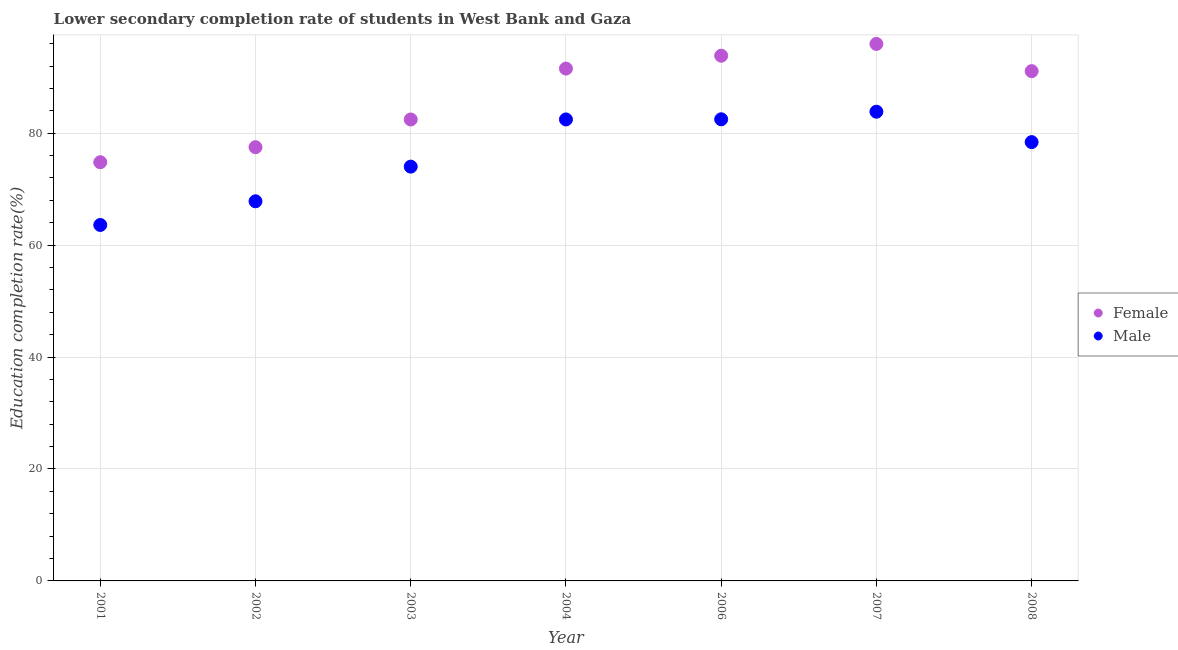How many different coloured dotlines are there?
Provide a succinct answer. 2. Is the number of dotlines equal to the number of legend labels?
Provide a succinct answer. Yes. What is the education completion rate of male students in 2002?
Offer a terse response. 67.83. Across all years, what is the maximum education completion rate of male students?
Make the answer very short. 83.84. Across all years, what is the minimum education completion rate of female students?
Your answer should be very brief. 74.81. What is the total education completion rate of female students in the graph?
Your answer should be compact. 607.18. What is the difference between the education completion rate of female students in 2001 and that in 2007?
Keep it short and to the point. -21.14. What is the difference between the education completion rate of male students in 2003 and the education completion rate of female students in 2007?
Provide a succinct answer. -21.92. What is the average education completion rate of male students per year?
Ensure brevity in your answer.  76.09. In the year 2008, what is the difference between the education completion rate of male students and education completion rate of female students?
Offer a very short reply. -12.68. What is the ratio of the education completion rate of female students in 2004 to that in 2006?
Provide a short and direct response. 0.98. Is the difference between the education completion rate of male students in 2002 and 2003 greater than the difference between the education completion rate of female students in 2002 and 2003?
Your response must be concise. No. What is the difference between the highest and the second highest education completion rate of female students?
Provide a succinct answer. 2.11. What is the difference between the highest and the lowest education completion rate of female students?
Offer a very short reply. 21.14. In how many years, is the education completion rate of male students greater than the average education completion rate of male students taken over all years?
Make the answer very short. 4. Does the education completion rate of male students monotonically increase over the years?
Provide a short and direct response. No. Is the education completion rate of male students strictly greater than the education completion rate of female students over the years?
Your answer should be compact. No. Is the education completion rate of male students strictly less than the education completion rate of female students over the years?
Offer a very short reply. Yes. How many years are there in the graph?
Give a very brief answer. 7. What is the difference between two consecutive major ticks on the Y-axis?
Your answer should be very brief. 20. Does the graph contain grids?
Your answer should be compact. Yes. Where does the legend appear in the graph?
Give a very brief answer. Center right. How are the legend labels stacked?
Give a very brief answer. Vertical. What is the title of the graph?
Provide a short and direct response. Lower secondary completion rate of students in West Bank and Gaza. Does "Excluding technical cooperation" appear as one of the legend labels in the graph?
Ensure brevity in your answer.  No. What is the label or title of the Y-axis?
Ensure brevity in your answer.  Education completion rate(%). What is the Education completion rate(%) in Female in 2001?
Provide a succinct answer. 74.81. What is the Education completion rate(%) of Male in 2001?
Provide a short and direct response. 63.6. What is the Education completion rate(%) of Female in 2002?
Your answer should be very brief. 77.5. What is the Education completion rate(%) in Male in 2002?
Make the answer very short. 67.83. What is the Education completion rate(%) of Female in 2003?
Keep it short and to the point. 82.45. What is the Education completion rate(%) in Male in 2003?
Ensure brevity in your answer.  74.02. What is the Education completion rate(%) in Female in 2004?
Offer a very short reply. 91.54. What is the Education completion rate(%) of Male in 2004?
Give a very brief answer. 82.46. What is the Education completion rate(%) of Female in 2006?
Offer a terse response. 93.84. What is the Education completion rate(%) of Male in 2006?
Make the answer very short. 82.48. What is the Education completion rate(%) of Female in 2007?
Provide a succinct answer. 95.95. What is the Education completion rate(%) of Male in 2007?
Give a very brief answer. 83.84. What is the Education completion rate(%) in Female in 2008?
Ensure brevity in your answer.  91.09. What is the Education completion rate(%) in Male in 2008?
Provide a short and direct response. 78.41. Across all years, what is the maximum Education completion rate(%) in Female?
Offer a terse response. 95.95. Across all years, what is the maximum Education completion rate(%) in Male?
Keep it short and to the point. 83.84. Across all years, what is the minimum Education completion rate(%) of Female?
Offer a very short reply. 74.81. Across all years, what is the minimum Education completion rate(%) of Male?
Offer a very short reply. 63.6. What is the total Education completion rate(%) in Female in the graph?
Keep it short and to the point. 607.18. What is the total Education completion rate(%) in Male in the graph?
Provide a short and direct response. 532.65. What is the difference between the Education completion rate(%) of Female in 2001 and that in 2002?
Give a very brief answer. -2.69. What is the difference between the Education completion rate(%) in Male in 2001 and that in 2002?
Provide a short and direct response. -4.23. What is the difference between the Education completion rate(%) of Female in 2001 and that in 2003?
Your response must be concise. -7.64. What is the difference between the Education completion rate(%) in Male in 2001 and that in 2003?
Offer a very short reply. -10.42. What is the difference between the Education completion rate(%) in Female in 2001 and that in 2004?
Offer a terse response. -16.73. What is the difference between the Education completion rate(%) in Male in 2001 and that in 2004?
Give a very brief answer. -18.86. What is the difference between the Education completion rate(%) in Female in 2001 and that in 2006?
Your response must be concise. -19.03. What is the difference between the Education completion rate(%) in Male in 2001 and that in 2006?
Ensure brevity in your answer.  -18.88. What is the difference between the Education completion rate(%) in Female in 2001 and that in 2007?
Your answer should be compact. -21.14. What is the difference between the Education completion rate(%) in Male in 2001 and that in 2007?
Offer a terse response. -20.24. What is the difference between the Education completion rate(%) in Female in 2001 and that in 2008?
Provide a short and direct response. -16.27. What is the difference between the Education completion rate(%) in Male in 2001 and that in 2008?
Ensure brevity in your answer.  -14.81. What is the difference between the Education completion rate(%) in Female in 2002 and that in 2003?
Your response must be concise. -4.95. What is the difference between the Education completion rate(%) of Male in 2002 and that in 2003?
Offer a terse response. -6.19. What is the difference between the Education completion rate(%) of Female in 2002 and that in 2004?
Offer a terse response. -14.05. What is the difference between the Education completion rate(%) in Male in 2002 and that in 2004?
Keep it short and to the point. -14.62. What is the difference between the Education completion rate(%) in Female in 2002 and that in 2006?
Make the answer very short. -16.34. What is the difference between the Education completion rate(%) of Male in 2002 and that in 2006?
Provide a short and direct response. -14.65. What is the difference between the Education completion rate(%) in Female in 2002 and that in 2007?
Offer a terse response. -18.45. What is the difference between the Education completion rate(%) in Male in 2002 and that in 2007?
Your response must be concise. -16. What is the difference between the Education completion rate(%) in Female in 2002 and that in 2008?
Your answer should be very brief. -13.59. What is the difference between the Education completion rate(%) in Male in 2002 and that in 2008?
Keep it short and to the point. -10.57. What is the difference between the Education completion rate(%) of Female in 2003 and that in 2004?
Your answer should be compact. -9.09. What is the difference between the Education completion rate(%) in Male in 2003 and that in 2004?
Make the answer very short. -8.43. What is the difference between the Education completion rate(%) in Female in 2003 and that in 2006?
Offer a very short reply. -11.39. What is the difference between the Education completion rate(%) of Male in 2003 and that in 2006?
Provide a succinct answer. -8.46. What is the difference between the Education completion rate(%) in Female in 2003 and that in 2007?
Your response must be concise. -13.5. What is the difference between the Education completion rate(%) of Male in 2003 and that in 2007?
Your answer should be compact. -9.81. What is the difference between the Education completion rate(%) of Female in 2003 and that in 2008?
Provide a short and direct response. -8.64. What is the difference between the Education completion rate(%) of Male in 2003 and that in 2008?
Ensure brevity in your answer.  -4.38. What is the difference between the Education completion rate(%) of Female in 2004 and that in 2006?
Your answer should be compact. -2.3. What is the difference between the Education completion rate(%) in Male in 2004 and that in 2006?
Your response must be concise. -0.03. What is the difference between the Education completion rate(%) in Female in 2004 and that in 2007?
Provide a succinct answer. -4.41. What is the difference between the Education completion rate(%) of Male in 2004 and that in 2007?
Offer a terse response. -1.38. What is the difference between the Education completion rate(%) of Female in 2004 and that in 2008?
Your answer should be compact. 0.46. What is the difference between the Education completion rate(%) of Male in 2004 and that in 2008?
Ensure brevity in your answer.  4.05. What is the difference between the Education completion rate(%) of Female in 2006 and that in 2007?
Keep it short and to the point. -2.11. What is the difference between the Education completion rate(%) of Male in 2006 and that in 2007?
Offer a very short reply. -1.35. What is the difference between the Education completion rate(%) of Female in 2006 and that in 2008?
Keep it short and to the point. 2.76. What is the difference between the Education completion rate(%) of Male in 2006 and that in 2008?
Make the answer very short. 4.08. What is the difference between the Education completion rate(%) in Female in 2007 and that in 2008?
Offer a terse response. 4.86. What is the difference between the Education completion rate(%) in Male in 2007 and that in 2008?
Your answer should be compact. 5.43. What is the difference between the Education completion rate(%) of Female in 2001 and the Education completion rate(%) of Male in 2002?
Ensure brevity in your answer.  6.98. What is the difference between the Education completion rate(%) of Female in 2001 and the Education completion rate(%) of Male in 2003?
Offer a very short reply. 0.79. What is the difference between the Education completion rate(%) of Female in 2001 and the Education completion rate(%) of Male in 2004?
Make the answer very short. -7.65. What is the difference between the Education completion rate(%) of Female in 2001 and the Education completion rate(%) of Male in 2006?
Keep it short and to the point. -7.67. What is the difference between the Education completion rate(%) of Female in 2001 and the Education completion rate(%) of Male in 2007?
Give a very brief answer. -9.02. What is the difference between the Education completion rate(%) in Female in 2001 and the Education completion rate(%) in Male in 2008?
Offer a very short reply. -3.6. What is the difference between the Education completion rate(%) in Female in 2002 and the Education completion rate(%) in Male in 2003?
Give a very brief answer. 3.47. What is the difference between the Education completion rate(%) of Female in 2002 and the Education completion rate(%) of Male in 2004?
Offer a very short reply. -4.96. What is the difference between the Education completion rate(%) in Female in 2002 and the Education completion rate(%) in Male in 2006?
Offer a very short reply. -4.99. What is the difference between the Education completion rate(%) of Female in 2002 and the Education completion rate(%) of Male in 2007?
Offer a terse response. -6.34. What is the difference between the Education completion rate(%) of Female in 2002 and the Education completion rate(%) of Male in 2008?
Offer a terse response. -0.91. What is the difference between the Education completion rate(%) of Female in 2003 and the Education completion rate(%) of Male in 2004?
Provide a succinct answer. -0.01. What is the difference between the Education completion rate(%) in Female in 2003 and the Education completion rate(%) in Male in 2006?
Give a very brief answer. -0.04. What is the difference between the Education completion rate(%) of Female in 2003 and the Education completion rate(%) of Male in 2007?
Make the answer very short. -1.39. What is the difference between the Education completion rate(%) in Female in 2003 and the Education completion rate(%) in Male in 2008?
Give a very brief answer. 4.04. What is the difference between the Education completion rate(%) of Female in 2004 and the Education completion rate(%) of Male in 2006?
Give a very brief answer. 9.06. What is the difference between the Education completion rate(%) of Female in 2004 and the Education completion rate(%) of Male in 2007?
Your answer should be compact. 7.71. What is the difference between the Education completion rate(%) in Female in 2004 and the Education completion rate(%) in Male in 2008?
Provide a succinct answer. 13.14. What is the difference between the Education completion rate(%) in Female in 2006 and the Education completion rate(%) in Male in 2007?
Your answer should be very brief. 10.01. What is the difference between the Education completion rate(%) in Female in 2006 and the Education completion rate(%) in Male in 2008?
Your answer should be compact. 15.44. What is the difference between the Education completion rate(%) in Female in 2007 and the Education completion rate(%) in Male in 2008?
Your response must be concise. 17.54. What is the average Education completion rate(%) in Female per year?
Keep it short and to the point. 86.74. What is the average Education completion rate(%) in Male per year?
Offer a very short reply. 76.09. In the year 2001, what is the difference between the Education completion rate(%) of Female and Education completion rate(%) of Male?
Give a very brief answer. 11.21. In the year 2002, what is the difference between the Education completion rate(%) of Female and Education completion rate(%) of Male?
Offer a very short reply. 9.67. In the year 2003, what is the difference between the Education completion rate(%) in Female and Education completion rate(%) in Male?
Your answer should be very brief. 8.42. In the year 2004, what is the difference between the Education completion rate(%) of Female and Education completion rate(%) of Male?
Offer a terse response. 9.09. In the year 2006, what is the difference between the Education completion rate(%) of Female and Education completion rate(%) of Male?
Offer a very short reply. 11.36. In the year 2007, what is the difference between the Education completion rate(%) in Female and Education completion rate(%) in Male?
Your answer should be very brief. 12.11. In the year 2008, what is the difference between the Education completion rate(%) of Female and Education completion rate(%) of Male?
Ensure brevity in your answer.  12.68. What is the ratio of the Education completion rate(%) of Female in 2001 to that in 2002?
Your response must be concise. 0.97. What is the ratio of the Education completion rate(%) of Male in 2001 to that in 2002?
Offer a terse response. 0.94. What is the ratio of the Education completion rate(%) in Female in 2001 to that in 2003?
Offer a terse response. 0.91. What is the ratio of the Education completion rate(%) of Male in 2001 to that in 2003?
Keep it short and to the point. 0.86. What is the ratio of the Education completion rate(%) in Female in 2001 to that in 2004?
Offer a terse response. 0.82. What is the ratio of the Education completion rate(%) of Male in 2001 to that in 2004?
Offer a very short reply. 0.77. What is the ratio of the Education completion rate(%) in Female in 2001 to that in 2006?
Provide a succinct answer. 0.8. What is the ratio of the Education completion rate(%) in Male in 2001 to that in 2006?
Keep it short and to the point. 0.77. What is the ratio of the Education completion rate(%) in Female in 2001 to that in 2007?
Offer a very short reply. 0.78. What is the ratio of the Education completion rate(%) of Male in 2001 to that in 2007?
Provide a succinct answer. 0.76. What is the ratio of the Education completion rate(%) in Female in 2001 to that in 2008?
Provide a succinct answer. 0.82. What is the ratio of the Education completion rate(%) in Male in 2001 to that in 2008?
Your answer should be very brief. 0.81. What is the ratio of the Education completion rate(%) of Male in 2002 to that in 2003?
Your answer should be compact. 0.92. What is the ratio of the Education completion rate(%) in Female in 2002 to that in 2004?
Offer a terse response. 0.85. What is the ratio of the Education completion rate(%) in Male in 2002 to that in 2004?
Ensure brevity in your answer.  0.82. What is the ratio of the Education completion rate(%) of Female in 2002 to that in 2006?
Offer a very short reply. 0.83. What is the ratio of the Education completion rate(%) in Male in 2002 to that in 2006?
Provide a succinct answer. 0.82. What is the ratio of the Education completion rate(%) of Female in 2002 to that in 2007?
Make the answer very short. 0.81. What is the ratio of the Education completion rate(%) in Male in 2002 to that in 2007?
Offer a terse response. 0.81. What is the ratio of the Education completion rate(%) in Female in 2002 to that in 2008?
Offer a very short reply. 0.85. What is the ratio of the Education completion rate(%) of Male in 2002 to that in 2008?
Make the answer very short. 0.87. What is the ratio of the Education completion rate(%) in Female in 2003 to that in 2004?
Your answer should be compact. 0.9. What is the ratio of the Education completion rate(%) in Male in 2003 to that in 2004?
Give a very brief answer. 0.9. What is the ratio of the Education completion rate(%) in Female in 2003 to that in 2006?
Provide a succinct answer. 0.88. What is the ratio of the Education completion rate(%) in Male in 2003 to that in 2006?
Make the answer very short. 0.9. What is the ratio of the Education completion rate(%) of Female in 2003 to that in 2007?
Give a very brief answer. 0.86. What is the ratio of the Education completion rate(%) of Male in 2003 to that in 2007?
Give a very brief answer. 0.88. What is the ratio of the Education completion rate(%) of Female in 2003 to that in 2008?
Offer a terse response. 0.91. What is the ratio of the Education completion rate(%) in Male in 2003 to that in 2008?
Provide a short and direct response. 0.94. What is the ratio of the Education completion rate(%) in Female in 2004 to that in 2006?
Keep it short and to the point. 0.98. What is the ratio of the Education completion rate(%) of Female in 2004 to that in 2007?
Your answer should be very brief. 0.95. What is the ratio of the Education completion rate(%) of Male in 2004 to that in 2007?
Provide a succinct answer. 0.98. What is the ratio of the Education completion rate(%) in Female in 2004 to that in 2008?
Keep it short and to the point. 1. What is the ratio of the Education completion rate(%) of Male in 2004 to that in 2008?
Provide a succinct answer. 1.05. What is the ratio of the Education completion rate(%) in Male in 2006 to that in 2007?
Make the answer very short. 0.98. What is the ratio of the Education completion rate(%) in Female in 2006 to that in 2008?
Ensure brevity in your answer.  1.03. What is the ratio of the Education completion rate(%) in Male in 2006 to that in 2008?
Make the answer very short. 1.05. What is the ratio of the Education completion rate(%) in Female in 2007 to that in 2008?
Your answer should be very brief. 1.05. What is the ratio of the Education completion rate(%) in Male in 2007 to that in 2008?
Keep it short and to the point. 1.07. What is the difference between the highest and the second highest Education completion rate(%) of Female?
Keep it short and to the point. 2.11. What is the difference between the highest and the second highest Education completion rate(%) of Male?
Ensure brevity in your answer.  1.35. What is the difference between the highest and the lowest Education completion rate(%) of Female?
Offer a terse response. 21.14. What is the difference between the highest and the lowest Education completion rate(%) in Male?
Ensure brevity in your answer.  20.24. 